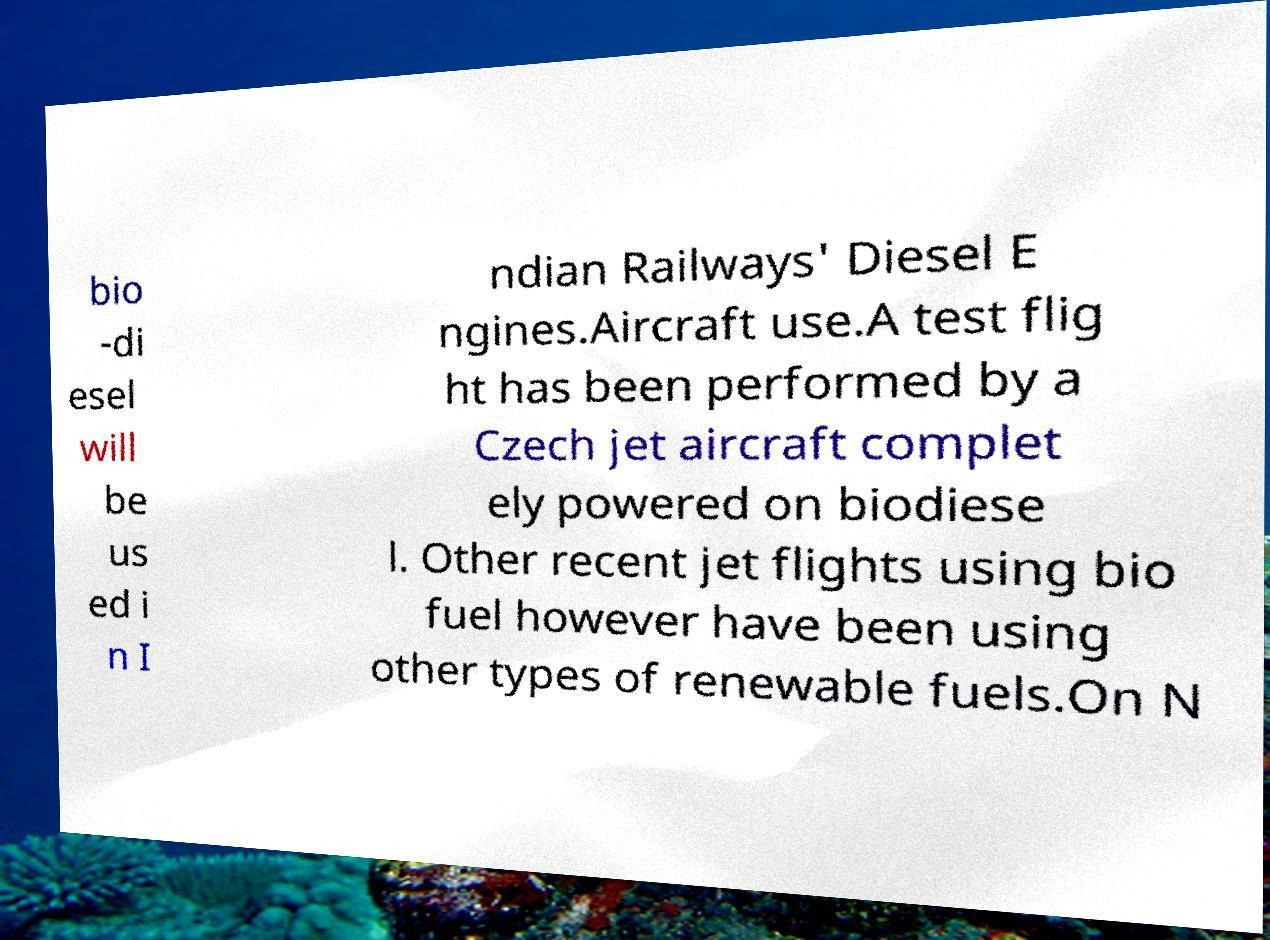Please read and relay the text visible in this image. What does it say? bio -di esel will be us ed i n I ndian Railways' Diesel E ngines.Aircraft use.A test flig ht has been performed by a Czech jet aircraft complet ely powered on biodiese l. Other recent jet flights using bio fuel however have been using other types of renewable fuels.On N 